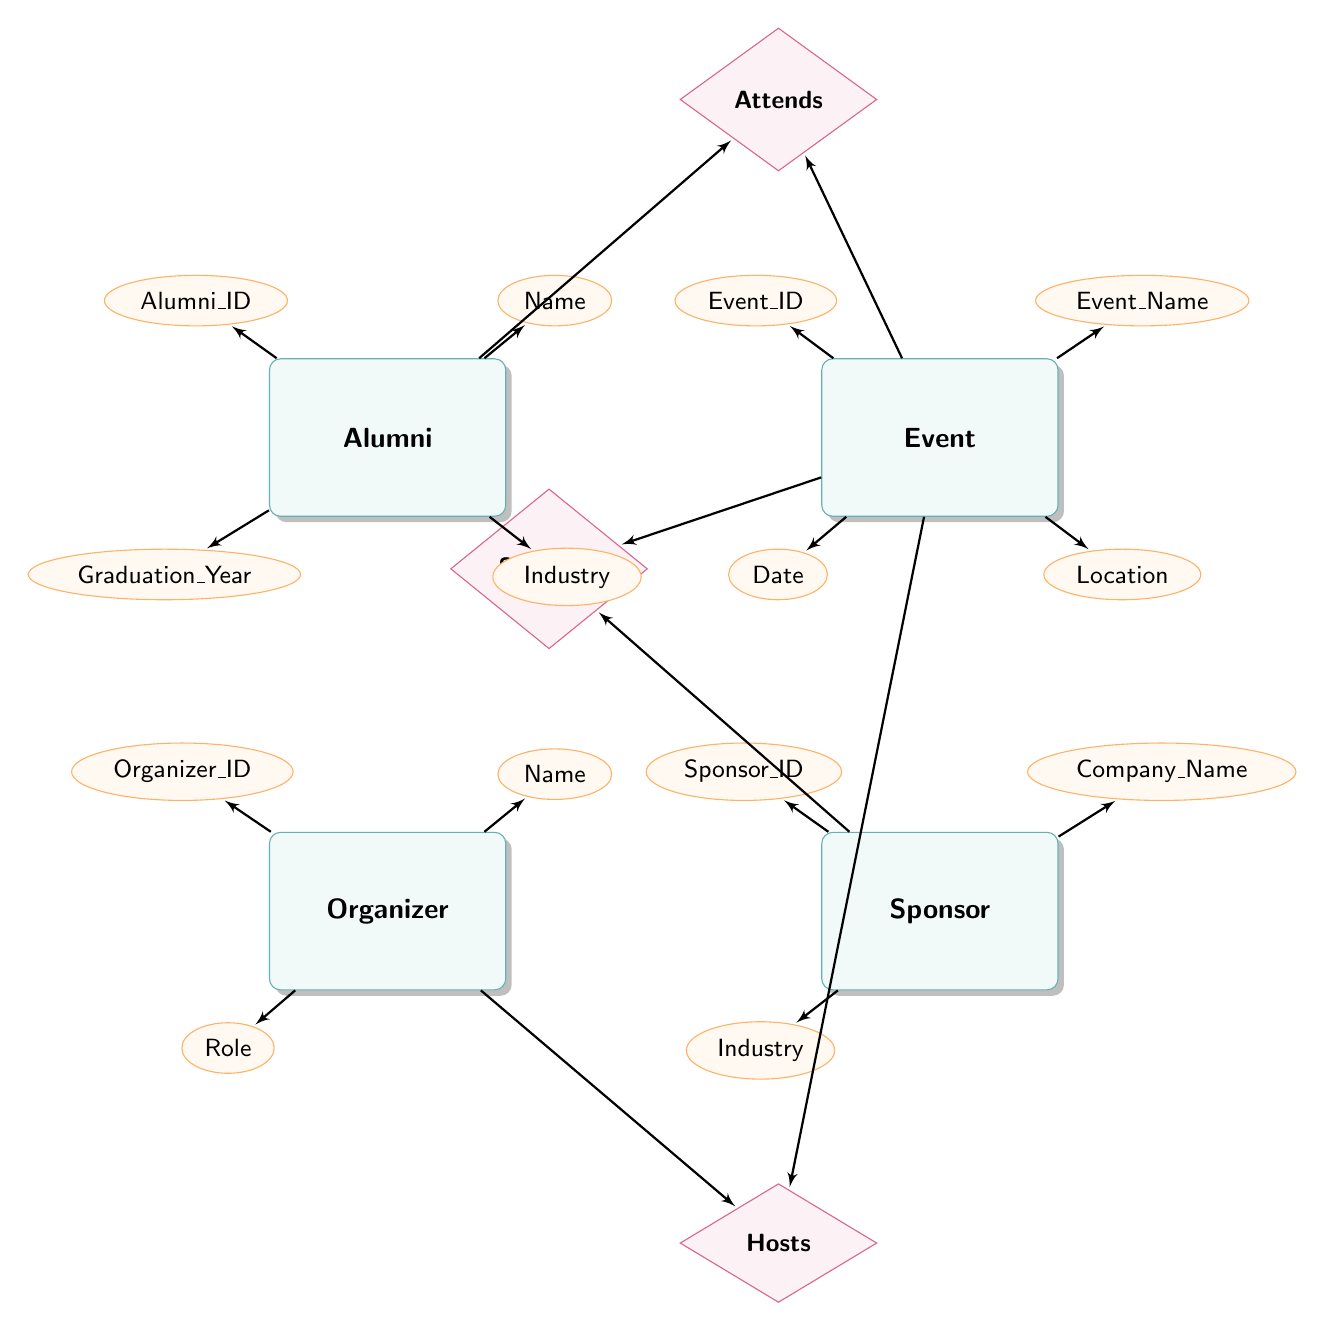What are the attributes of the Alumni entity? The Alumni entity has four attributes: Alumni_ID, Name, Graduation_Year, and Industry. These attributes are indicated by the ellipses connected to the Alumni rectangle in the diagram.
Answer: Alumni_ID, Name, Graduation_Year, Industry What is the relationship between Alumni and Event? The relationship between Alumni and Event is represented by the diamond labeled "Attends." This indicates that Alumni have a connection to events they attend.
Answer: Attends How many entities are there in the diagram? By counting the rectangles that represent entities—Alumni, Event, Organizer, and Sponsor—we find a total of four entities in the diagram.
Answer: 4 What type of relationship connects Sponsor and Event? The type of relationship that connects Sponsor and Event is labeled "Sponsors." This is shown by the diamond connecting the Sponsor entity to the Event entity.
Answer: Sponsors What attribute is associated with the relationship "Attends"? The relationship "Attends" has one associated attribute, which is RSVP_Status. This is defined by the line connecting to the diamond representing the relationship.
Answer: RSVP_Status How many attributes are associated with the Event entity? The Event entity has four attributes: Event_ID, Event_Name, Date, and Location. These attributes are shown by the ellipses connected to the Event rectangle in the diagram.
Answer: 4 What is the contact information for the Organizer? The attributes related to Organizer do not include specific 'Contact Information,' but it has four attributes, one being Contact_Info. The contact information can be found in the diagram’s ellipses connected to the Organizer entity.
Answer: Contact_Info Can an Event have multiple Sponsors? Yes, based on the diagram, since the "Sponsors" relationship connects the Sponsor to Event, it indicates that multiple sponsors can contribute to a single event.
Answer: Yes What relationships does the Organizer have with the Event? The Organizer has a "Hosts" relationship with the Event, indicating that they are responsible for organizing that particular event. This is shown by the diamond labeled "Hosts" connecting both entities.
Answer: Hosts 